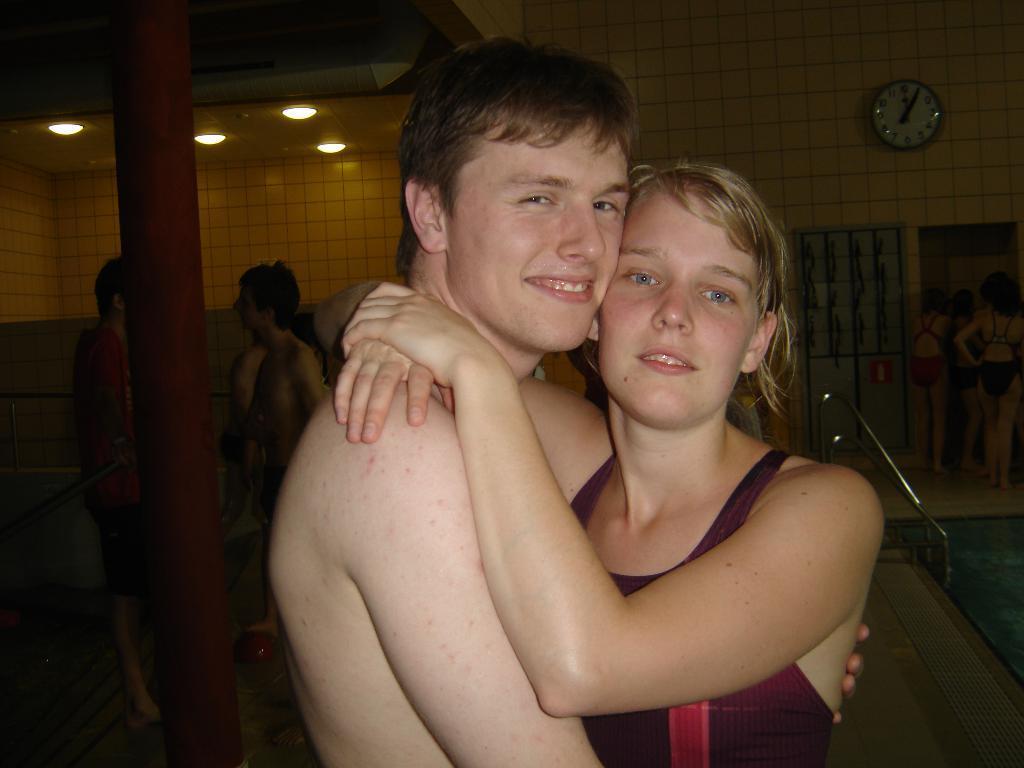Could you give a brief overview of what you see in this image? In this image in the foreground there is one man and one woman who are hugging each other, and in the background there are some people, wall, clock, mirror. And on the right side of the image there is pool and some poles, and on the left side there is a pole. At the top there is ceiling. 